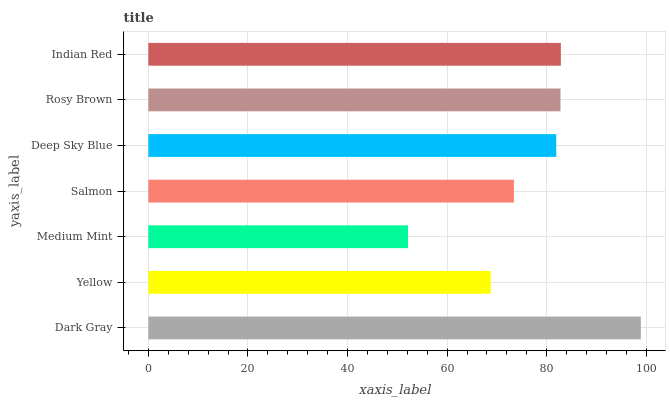Is Medium Mint the minimum?
Answer yes or no. Yes. Is Dark Gray the maximum?
Answer yes or no. Yes. Is Yellow the minimum?
Answer yes or no. No. Is Yellow the maximum?
Answer yes or no. No. Is Dark Gray greater than Yellow?
Answer yes or no. Yes. Is Yellow less than Dark Gray?
Answer yes or no. Yes. Is Yellow greater than Dark Gray?
Answer yes or no. No. Is Dark Gray less than Yellow?
Answer yes or no. No. Is Deep Sky Blue the high median?
Answer yes or no. Yes. Is Deep Sky Blue the low median?
Answer yes or no. Yes. Is Medium Mint the high median?
Answer yes or no. No. Is Yellow the low median?
Answer yes or no. No. 